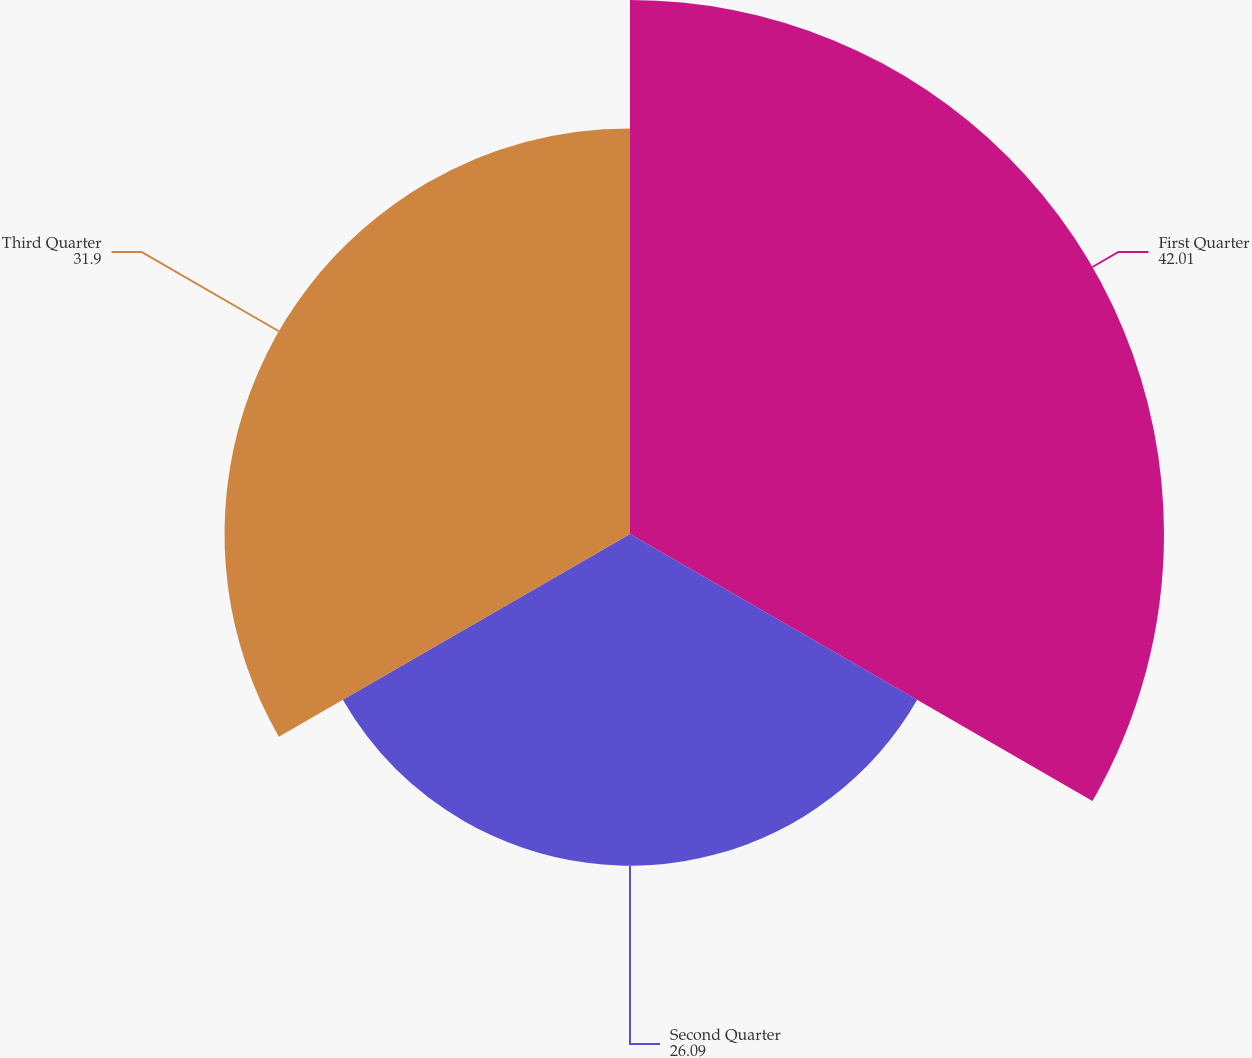Convert chart. <chart><loc_0><loc_0><loc_500><loc_500><pie_chart><fcel>First Quarter<fcel>Second Quarter<fcel>Third Quarter<nl><fcel>42.01%<fcel>26.09%<fcel>31.9%<nl></chart> 